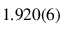<formula> <loc_0><loc_0><loc_500><loc_500>1 . 9 2 0 ( 6 )</formula> 